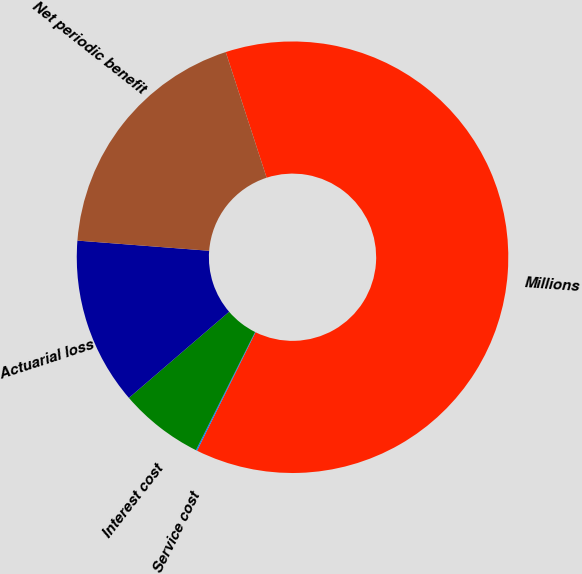Convert chart to OTSL. <chart><loc_0><loc_0><loc_500><loc_500><pie_chart><fcel>Millions<fcel>Service cost<fcel>Interest cost<fcel>Actuarial loss<fcel>Net periodic benefit<nl><fcel>62.3%<fcel>0.09%<fcel>6.31%<fcel>12.53%<fcel>18.76%<nl></chart> 